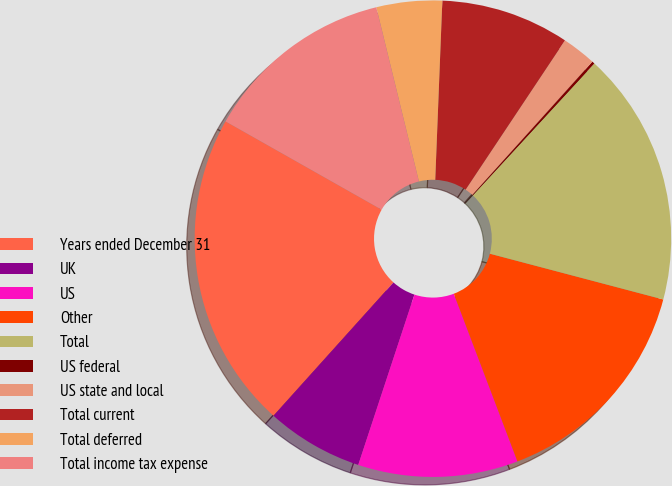<chart> <loc_0><loc_0><loc_500><loc_500><pie_chart><fcel>Years ended December 31<fcel>UK<fcel>US<fcel>Other<fcel>Total<fcel>US federal<fcel>US state and local<fcel>Total current<fcel>Total deferred<fcel>Total income tax expense<nl><fcel>21.53%<fcel>6.59%<fcel>10.85%<fcel>15.12%<fcel>17.26%<fcel>0.18%<fcel>2.32%<fcel>8.72%<fcel>4.45%<fcel>12.99%<nl></chart> 